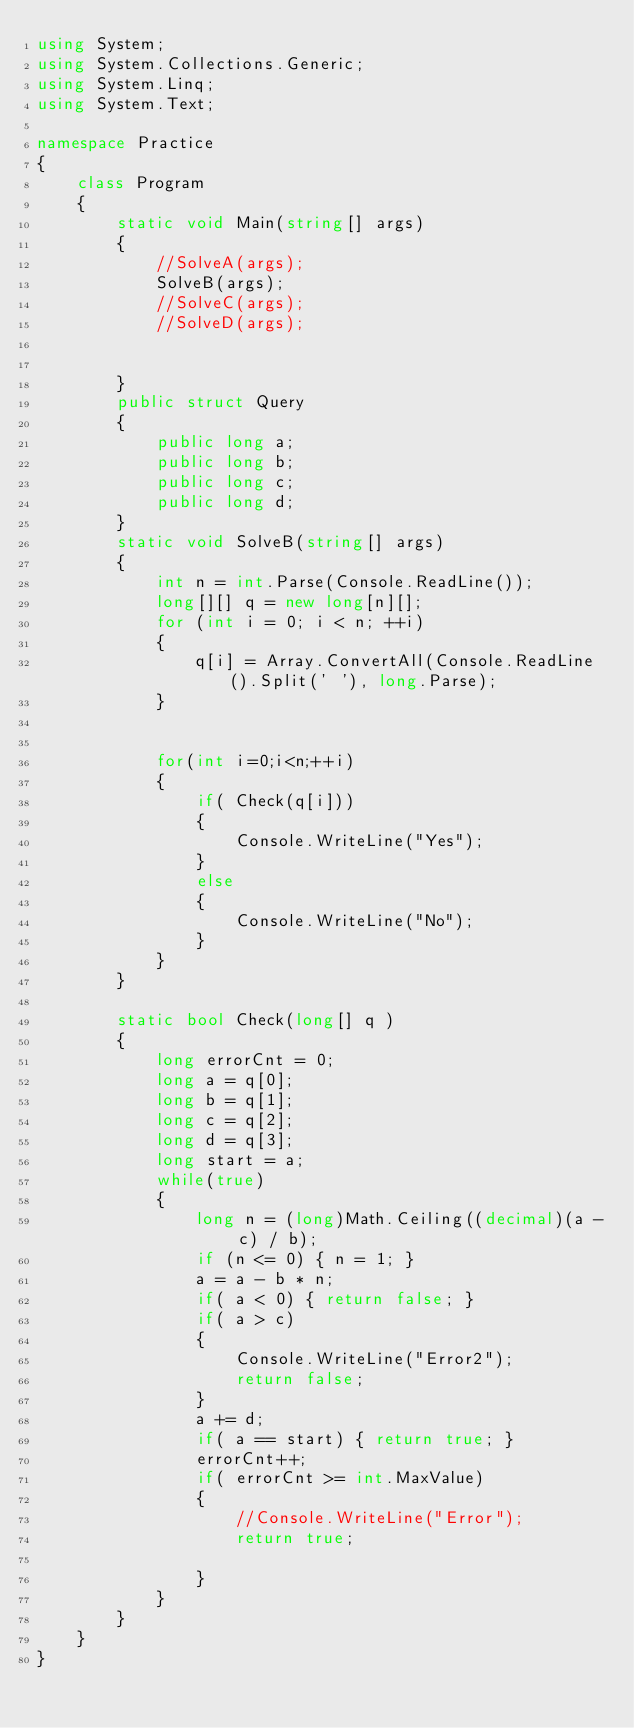<code> <loc_0><loc_0><loc_500><loc_500><_C#_>using System;
using System.Collections.Generic;
using System.Linq;
using System.Text;

namespace Practice
{
    class Program
    {
        static void Main(string[] args)
        {
            //SolveA(args);
            SolveB(args);
            //SolveC(args);
            //SolveD(args);


        }
        public struct Query
        {
            public long a;
            public long b;
            public long c;
            public long d;
        }
        static void SolveB(string[] args)
        {
            int n = int.Parse(Console.ReadLine());
            long[][] q = new long[n][];
            for (int i = 0; i < n; ++i)
            {
                q[i] = Array.ConvertAll(Console.ReadLine().Split(' '), long.Parse);
            }

            
            for(int i=0;i<n;++i)
            {
                if( Check(q[i]))
                {
                    Console.WriteLine("Yes");
                }
                else
                {
                    Console.WriteLine("No");
                }
            }
        }

        static bool Check(long[] q )
        {
            long errorCnt = 0;
            long a = q[0];
            long b = q[1];
            long c = q[2];
            long d = q[3];
            long start = a;
            while(true)
            {
                long n = (long)Math.Ceiling((decimal)(a - c) / b);
                if (n <= 0) { n = 1; }
                a = a - b * n;
                if( a < 0) { return false; }
                if( a > c)
                {
                    Console.WriteLine("Error2");
                    return false;
                }
                a += d;
                if( a == start) { return true; }
                errorCnt++;
                if( errorCnt >= int.MaxValue)
                {
                    //Console.WriteLine("Error");
                    return true;

                }
            }
        }
    }
}
</code> 